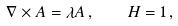Convert formula to latex. <formula><loc_0><loc_0><loc_500><loc_500>\nabla \times { A } = \lambda { A } \, , \quad H = 1 \, ,</formula> 